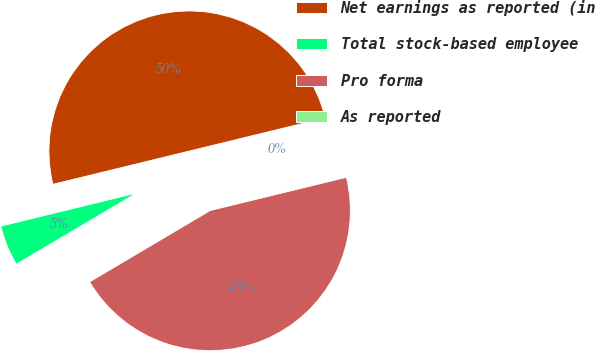<chart> <loc_0><loc_0><loc_500><loc_500><pie_chart><fcel>Net earnings as reported (in<fcel>Total stock-based employee<fcel>Pro forma<fcel>As reported<nl><fcel>50.0%<fcel>4.7%<fcel>45.3%<fcel>0.0%<nl></chart> 